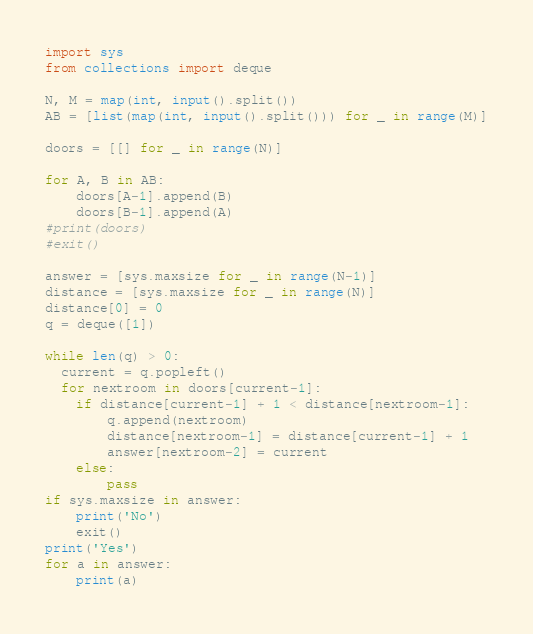Convert code to text. <code><loc_0><loc_0><loc_500><loc_500><_Python_>import sys
from collections import deque

N, M = map(int, input().split())
AB = [list(map(int, input().split())) for _ in range(M)]

doors = [[] for _ in range(N)]

for A, B in AB:
    doors[A-1].append(B)
    doors[B-1].append(A)
#print(doors)
#exit()

answer = [sys.maxsize for _ in range(N-1)]
distance = [sys.maxsize for _ in range(N)]
distance[0] = 0
q = deque([1])

while len(q) > 0:
  current = q.popleft()
  for nextroom in doors[current-1]:
    if distance[current-1] + 1 < distance[nextroom-1]:
        q.append(nextroom)
        distance[nextroom-1] = distance[current-1] + 1
        answer[nextroom-2] = current
    else:
        pass
if sys.maxsize in answer:
    print('No')
    exit()
print('Yes')
for a in answer:
    print(a)
</code> 